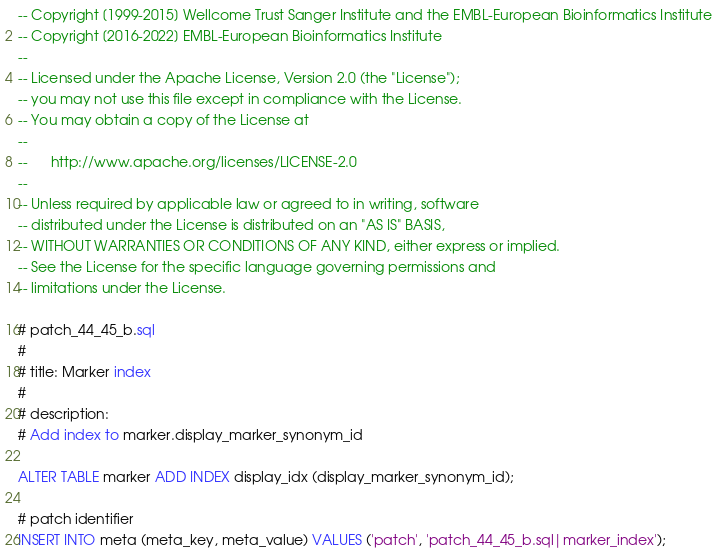Convert code to text. <code><loc_0><loc_0><loc_500><loc_500><_SQL_>-- Copyright [1999-2015] Wellcome Trust Sanger Institute and the EMBL-European Bioinformatics Institute
-- Copyright [2016-2022] EMBL-European Bioinformatics Institute
-- 
-- Licensed under the Apache License, Version 2.0 (the "License");
-- you may not use this file except in compliance with the License.
-- You may obtain a copy of the License at
-- 
--      http://www.apache.org/licenses/LICENSE-2.0
-- 
-- Unless required by applicable law or agreed to in writing, software
-- distributed under the License is distributed on an "AS IS" BASIS,
-- WITHOUT WARRANTIES OR CONDITIONS OF ANY KIND, either express or implied.
-- See the License for the specific language governing permissions and
-- limitations under the License.

# patch_44_45_b.sql
#
# title: Marker index
#
# description: 
# Add index to marker.display_marker_synonym_id

ALTER TABLE marker ADD INDEX display_idx (display_marker_synonym_id);

# patch identifier
INSERT INTO meta (meta_key, meta_value) VALUES ('patch', 'patch_44_45_b.sql|marker_index');


</code> 